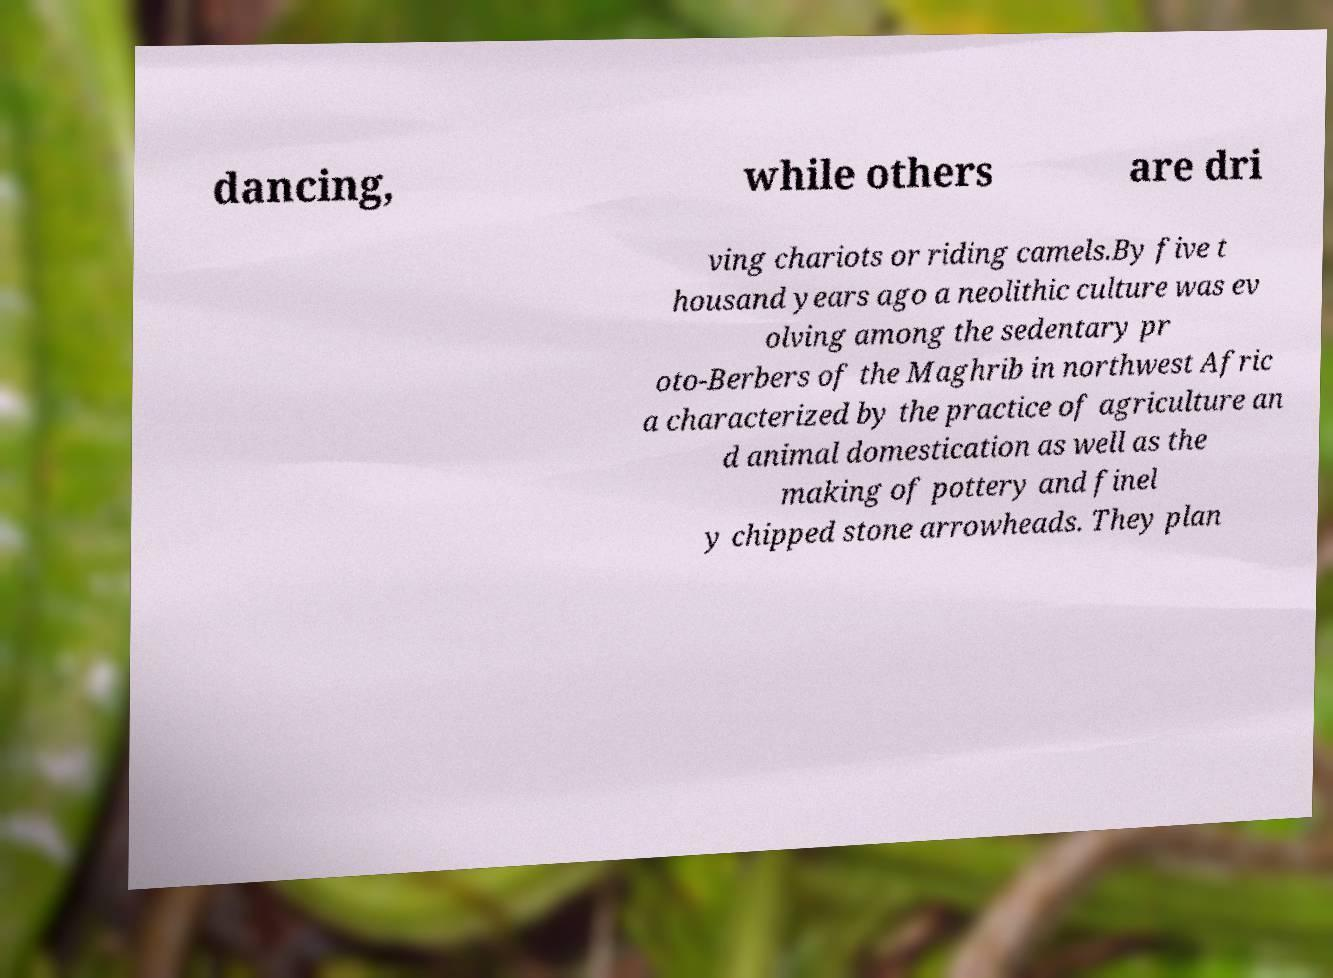Could you assist in decoding the text presented in this image and type it out clearly? dancing, while others are dri ving chariots or riding camels.By five t housand years ago a neolithic culture was ev olving among the sedentary pr oto-Berbers of the Maghrib in northwest Afric a characterized by the practice of agriculture an d animal domestication as well as the making of pottery and finel y chipped stone arrowheads. They plan 